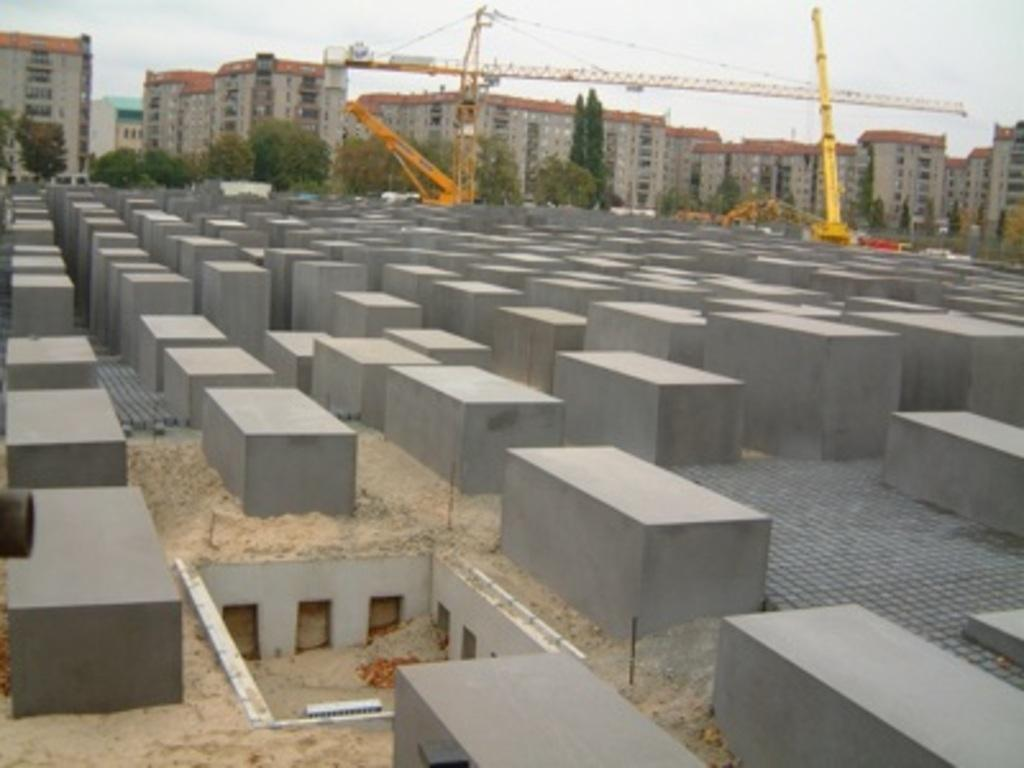What objects are on the ground in the image? There are blocks on the ground in the image. What structure is located beside the trees in the image? There is a crane beside the trees in the image. What type of man-made structures can be seen in the image? Buildings are visible in the image. What is visible at the top of the image? The sky is visible at the top of the image. Where is the hose connected to in the image? There is no hose present in the image. What type of gate can be seen in the image? There is no gate present in the image. 